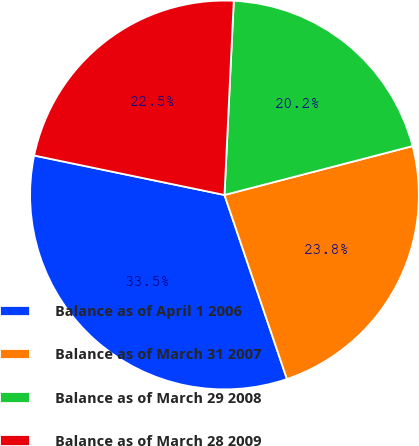Convert chart. <chart><loc_0><loc_0><loc_500><loc_500><pie_chart><fcel>Balance as of April 1 2006<fcel>Balance as of March 31 2007<fcel>Balance as of March 29 2008<fcel>Balance as of March 28 2009<nl><fcel>33.46%<fcel>23.84%<fcel>20.19%<fcel>22.51%<nl></chart> 